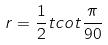Convert formula to latex. <formula><loc_0><loc_0><loc_500><loc_500>r = \frac { 1 } { 2 } t c o t \frac { \pi } { 9 0 }</formula> 